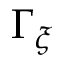Convert formula to latex. <formula><loc_0><loc_0><loc_500><loc_500>\Gamma _ { \xi }</formula> 